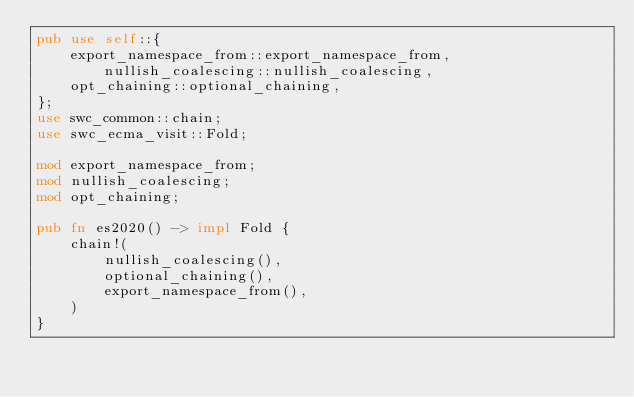<code> <loc_0><loc_0><loc_500><loc_500><_Rust_>pub use self::{
    export_namespace_from::export_namespace_from, nullish_coalescing::nullish_coalescing,
    opt_chaining::optional_chaining,
};
use swc_common::chain;
use swc_ecma_visit::Fold;

mod export_namespace_from;
mod nullish_coalescing;
mod opt_chaining;

pub fn es2020() -> impl Fold {
    chain!(
        nullish_coalescing(),
        optional_chaining(),
        export_namespace_from(),
    )
}
</code> 